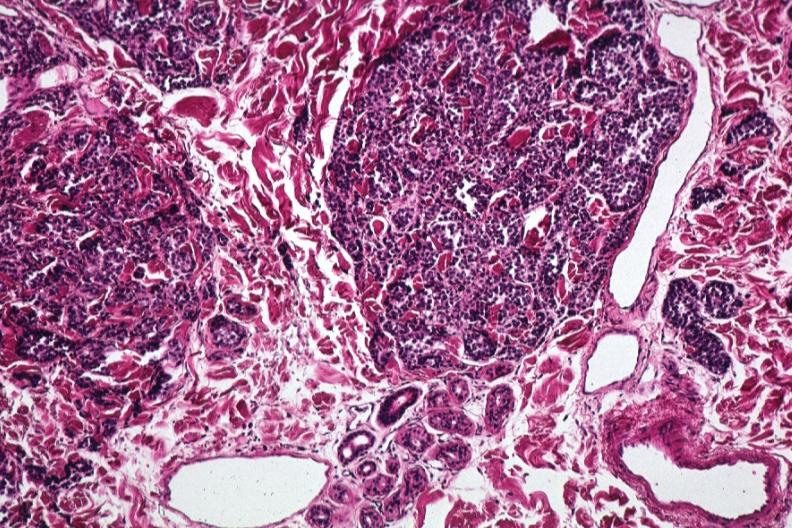does rheumatoid arthritis with vasculitis show med lesion extension to sweat glands same as 2?
Answer the question using a single word or phrase. No 